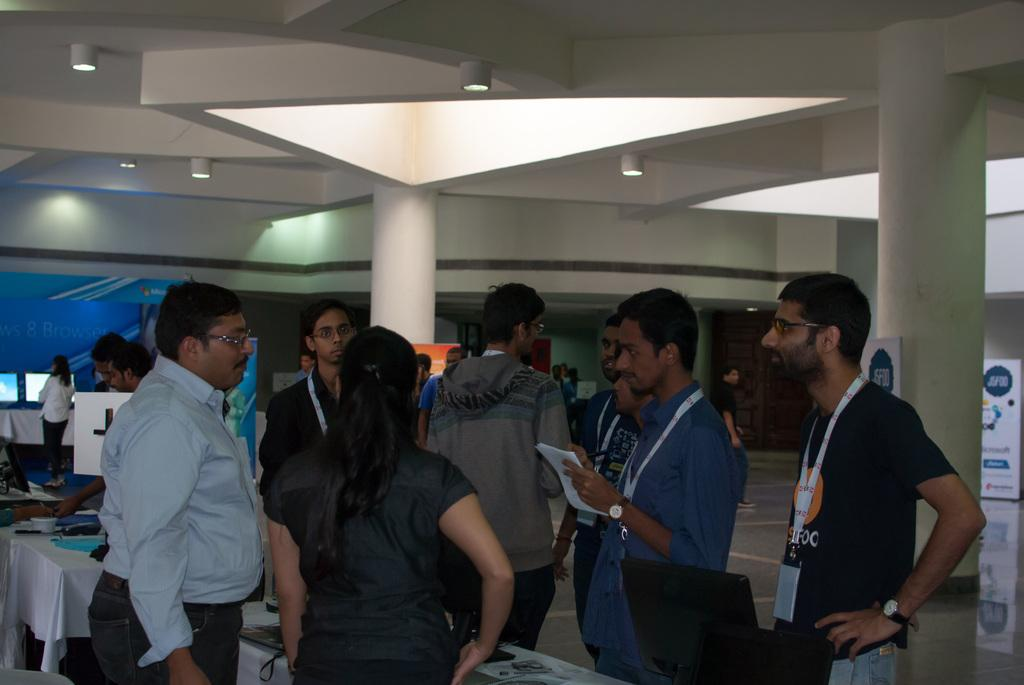How many people are in the group visible in the image? There is a group of people in the image, but the exact number cannot be determined from the provided facts. What can be seen covering the tables in the image? There are tablecloths in the image. What architectural features are present in the image? Pillars are present in the image. What type of advertising is visible in the image? Hoardings are visible in the image. What can be used for illumination in the image? Lights are in the image. What is in the background of the image? There is a wall and screens in the background of the image. What type of coast can be seen in the image? There is no coast visible in the image. How does the stomach of the person in the image feel? There is no information about the stomach of any person in the image. 